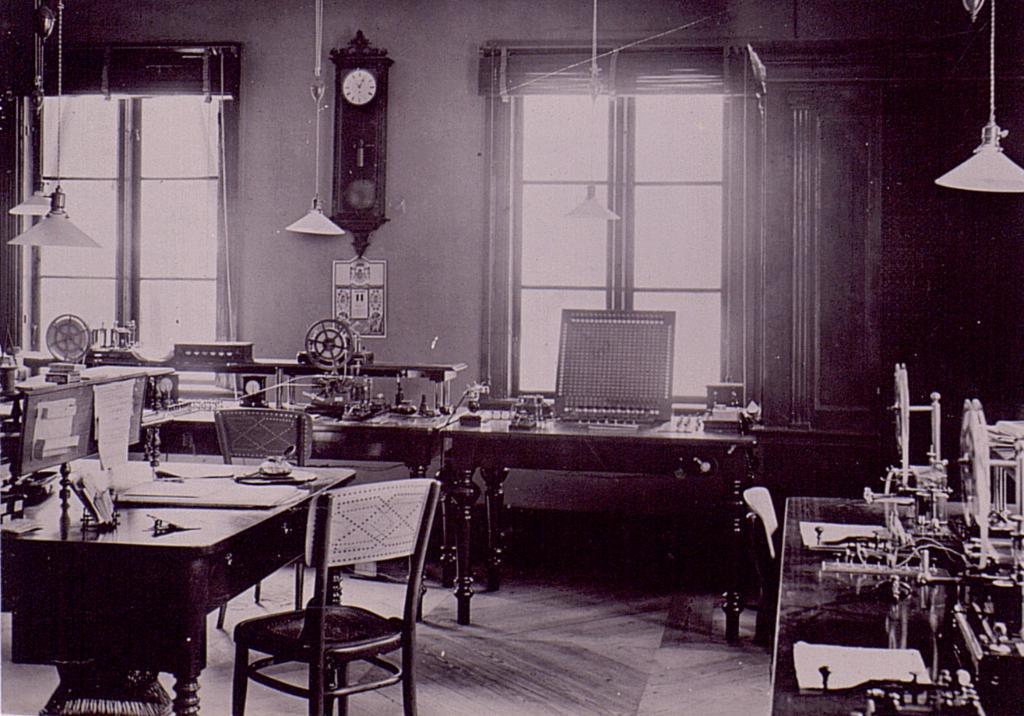In one or two sentences, can you explain what this image depicts? In the image there is a wall, clock, windows, hanging lamps, tables, chairs and a few other objects. 